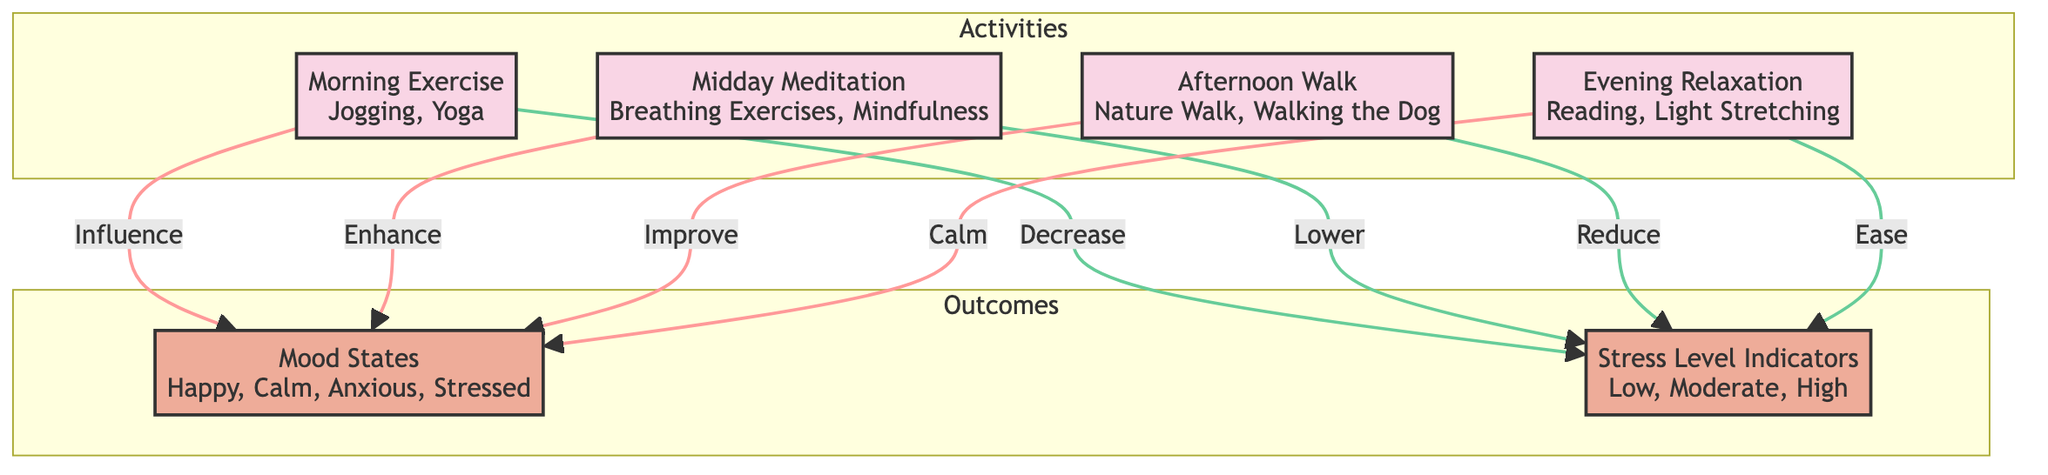What activities are included in the morning? The diagram lists "Jogging, Yoga" under the "Morning Exercise" activity. Therefore, I will refer back to the node representing morning activities to obtain this information.
Answer: Jogging, Yoga How many main activities are there? The diagram presents a total of four activities within the "Activities" subgraph: Morning Exercise, Midday Meditation, Afternoon Walk, and Evening Relaxation. By counting these nodes, we can easily ascertain the total number.
Answer: 4 Which mood state is influenced by the evening relaxation? According to the diagram, the "Evening Relaxation" activity has a direct influence on the "Mood States" with the phrase "Calm," indicating a positive effect from this activity. Hence, this is derived from the arrow leading from Evening Relaxation towards Mood States.
Answer: Calm What effect does midday meditation have on stress levels? The diagram indicates that "Midday Meditation" has a "Lower" effect on the "Stress Level Indicators." This relationship can be traced through the arrow that connects the activity to the stress level indicator, demonstrating how meditation influences stress.
Answer: Lower If a person engages in morning exercise, what is the expected change on their mood state? The relationship depicted in the diagram shows that "Morning Exercise" has an "Influence" on the "Mood States," specifically pointing towards the positive states like "Happy." By following the arrow from the morning activity to mood states, we see evidence of this influence.
Answer: Influence What is the nature of the relationship between afternoon walk and stress levels? The diagram states that "Afternoon Walk" is associated with a "Reduce" outcome for "Stress Level Indicators." This indicates that engaging in this activity is expected to decrease stress levels, which can be inferred from the directional link present in the diagram.
Answer: Reduce Which activity enhances mood states according to the diagram? The diagram shows that "Midday Meditation" is linked with the outcome of "Enhance" under mood states, indicating its positive contribution to improving one’s mood. This is directly illustrated by the arrow pointing from the midday activity to the mood states.
Answer: Midday Meditation How many different mood states are listed in the diagram? The "Mood States" indicates four options: Happy, Calm, Anxious, and Stressed. Counting the different states presented in the corresponding node allows for this conclusion.
Answer: 4 